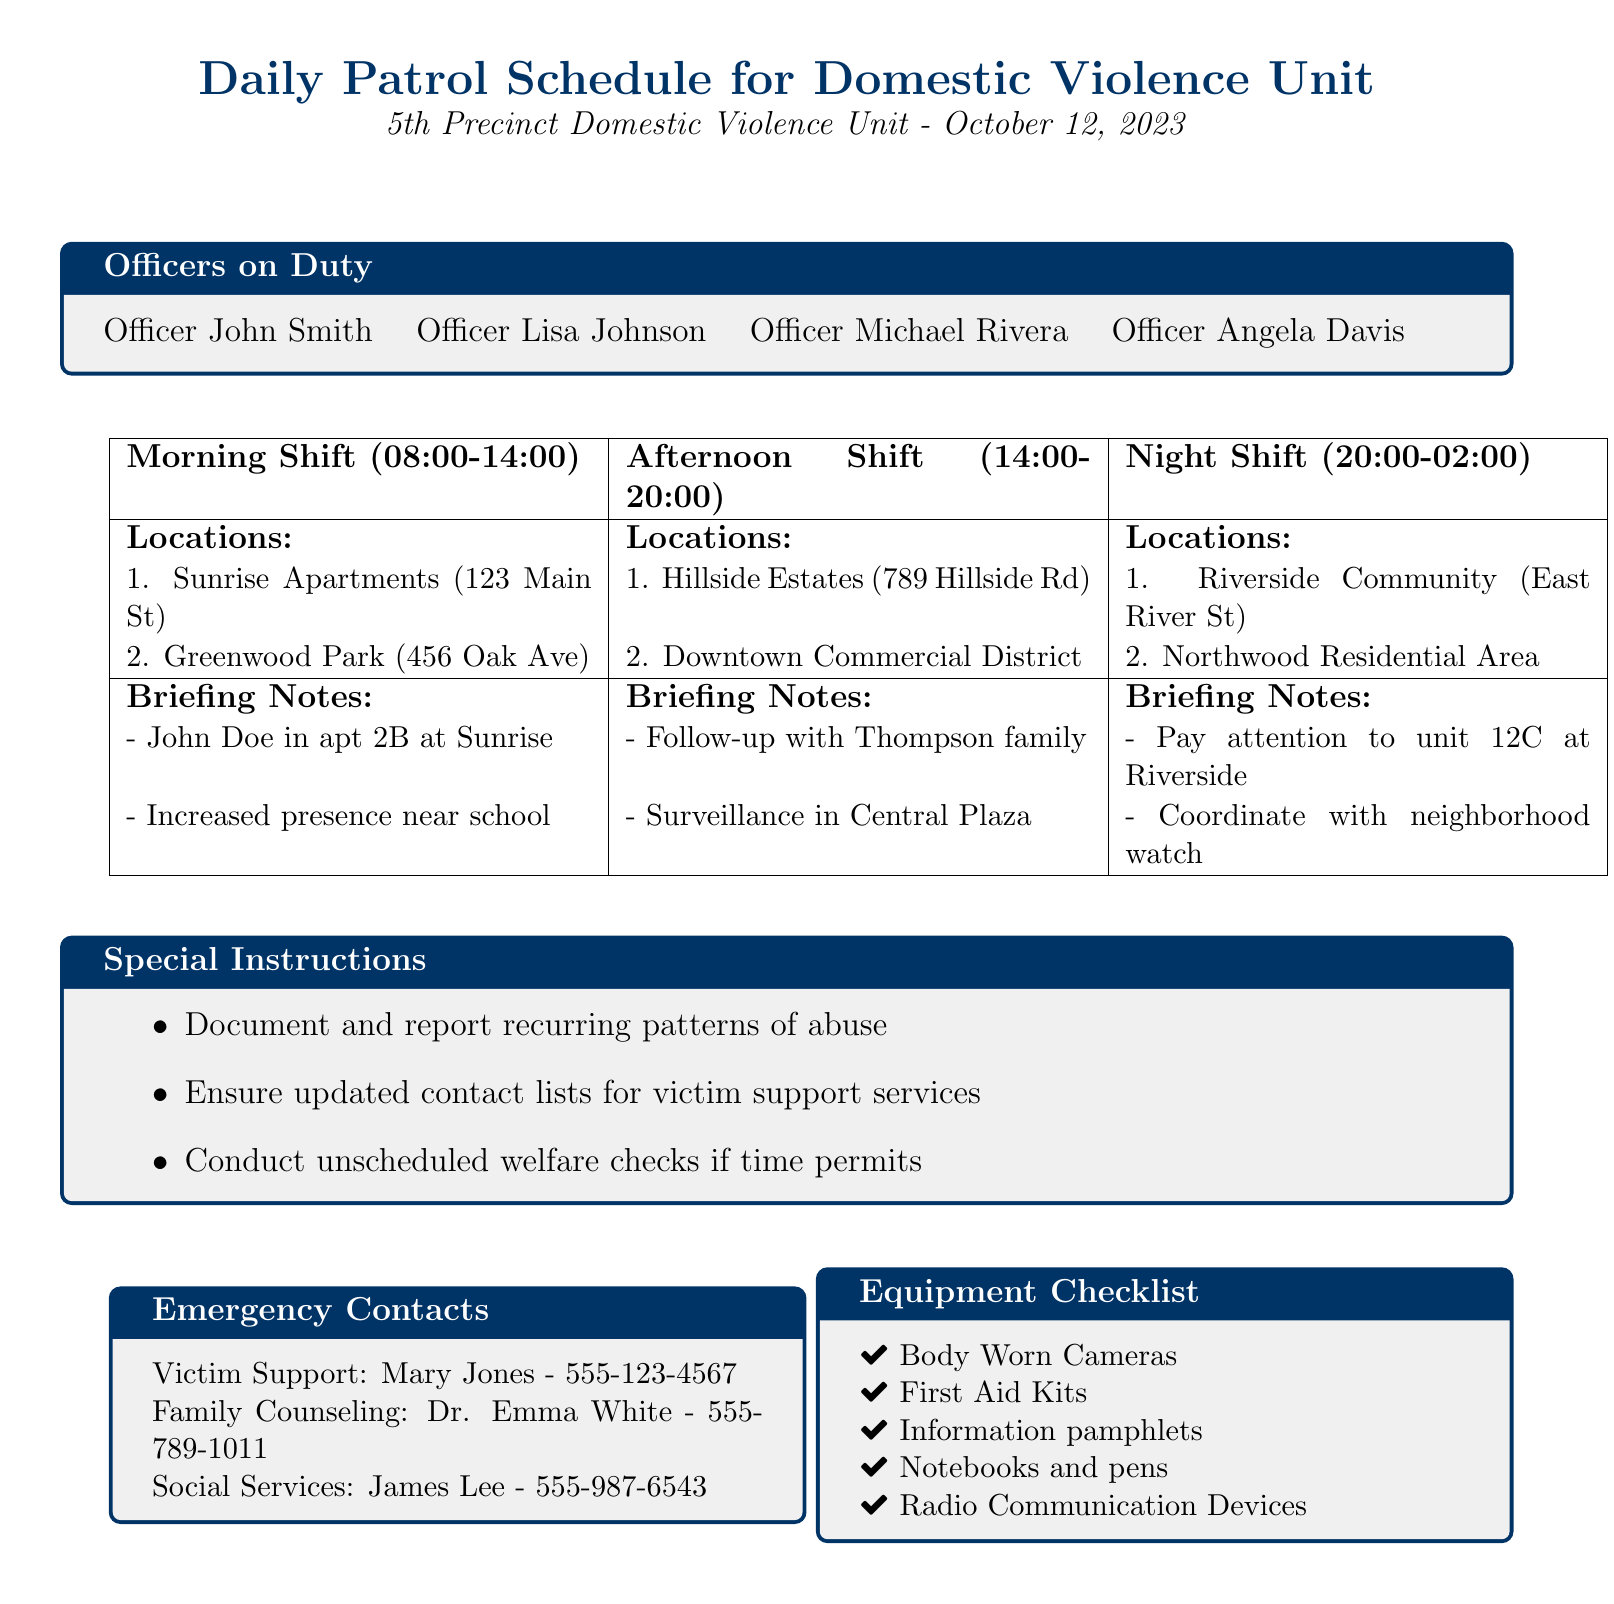What is the date of the schedule? The date is mentioned in the title of the document as October 12, 2023.
Answer: October 12, 2023 Who is the officer on duty during the morning shift? The names of officers on duty during each shift are listed in the "Officers on Duty" box.
Answer: Officer John Smith What is the first location for the afternoon shift? The first location for the afternoon shift is specified in the table of locations for that shift.
Answer: Hillside Estates What are the brief notes for the night shift? The brief notes can be found in the corresponding column of the table under "Briefing Notes" for the night shift.
Answer: Pay attention to unit 12C at Riverside What is one of the special instructions listed? Special instructions can be found in a box specifically for that purpose, including various actionable items.
Answer: Document and report recurring patterns of abuse How many officers are listed on duty? The number of officers is given in the "Officers on Duty" section of the document.
Answer: Four Who should be contacted for family counseling? The emergency contacts section details who to contact for various services, including family counseling.
Answer: Dr. Emma White What is one item listed in the equipment checklist? The equipment checklist lists various items that should be available during the patrol.
Answer: Body Worn Cameras What time does the night shift start? The start time of each shift is indicated in the schedule table for that shift.
Answer: 20:00 